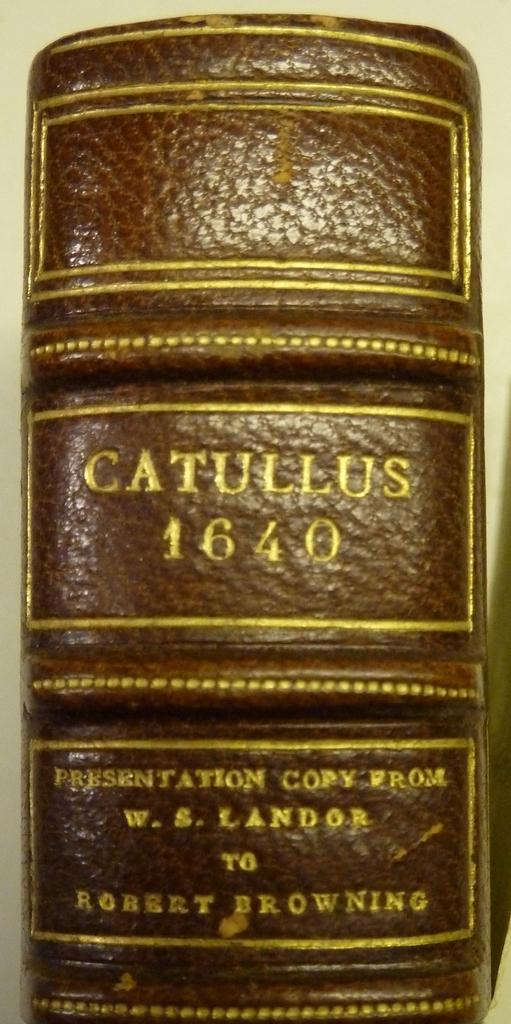<image>
Share a concise interpretation of the image provided. The leather bound spine of catullus 1640 written by w. s. Landor. 